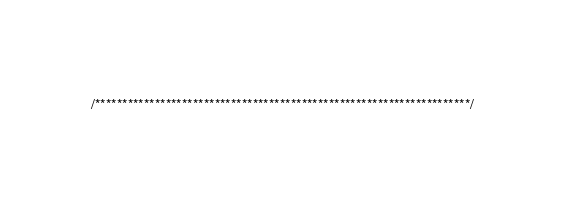<code> <loc_0><loc_0><loc_500><loc_500><_C_>/*********************************************************************/</code> 